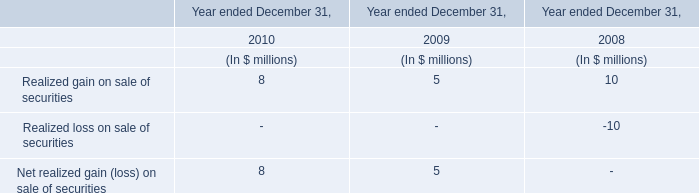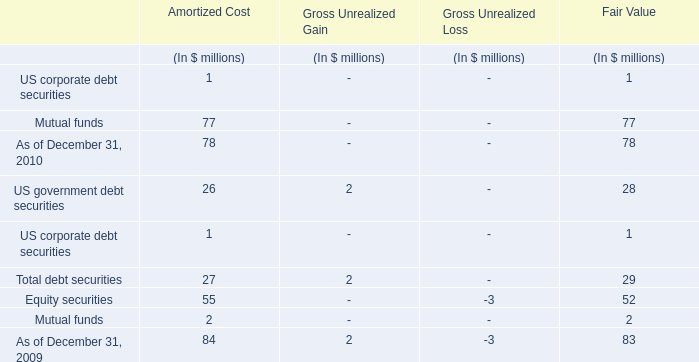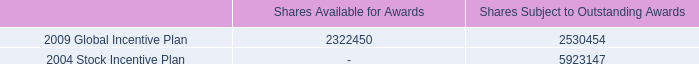If Realized gain on sale of securities same growth rate develops with the s in 2010, what will it reach in 2011? (in million) 
Computations: (8 * (1 + ((8 - 5) / 8)))
Answer: 11.0. 